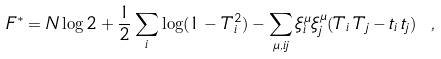<formula> <loc_0><loc_0><loc_500><loc_500>F ^ { * } = N \log 2 + \frac { 1 } { 2 } \sum _ { i } \log ( 1 - T _ { i } ^ { 2 } ) - \sum _ { \mu , i j } \xi _ { i } ^ { \mu } \xi _ { j } ^ { \mu } ( T _ { i } \, T _ { j } - t _ { i } \, t _ { j } ) \ ,</formula> 